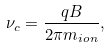<formula> <loc_0><loc_0><loc_500><loc_500>\nu _ { c } = \frac { q B } { 2 \pi m _ { i o n } } ,</formula> 